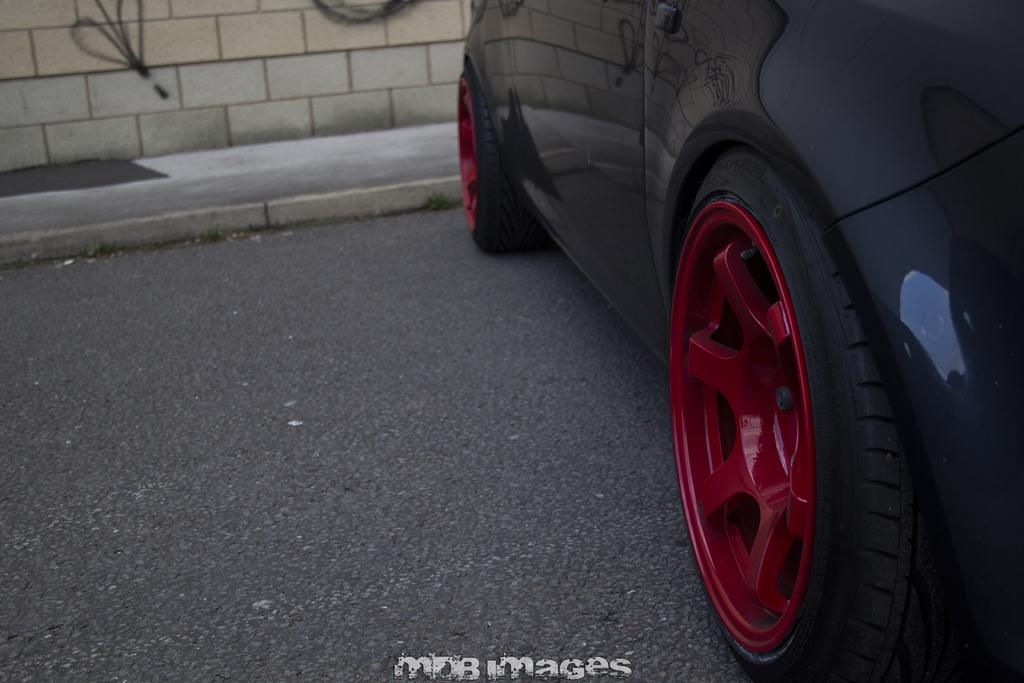What is located on the path in the image? There is a car on the path in the image. What can be seen at the bottom of the image? There is some text visible at the bottom of the image. What is in the background of the image? There is a wall in the background of the image. What color is the ear that is visible in the image? There is no ear present in the image. 